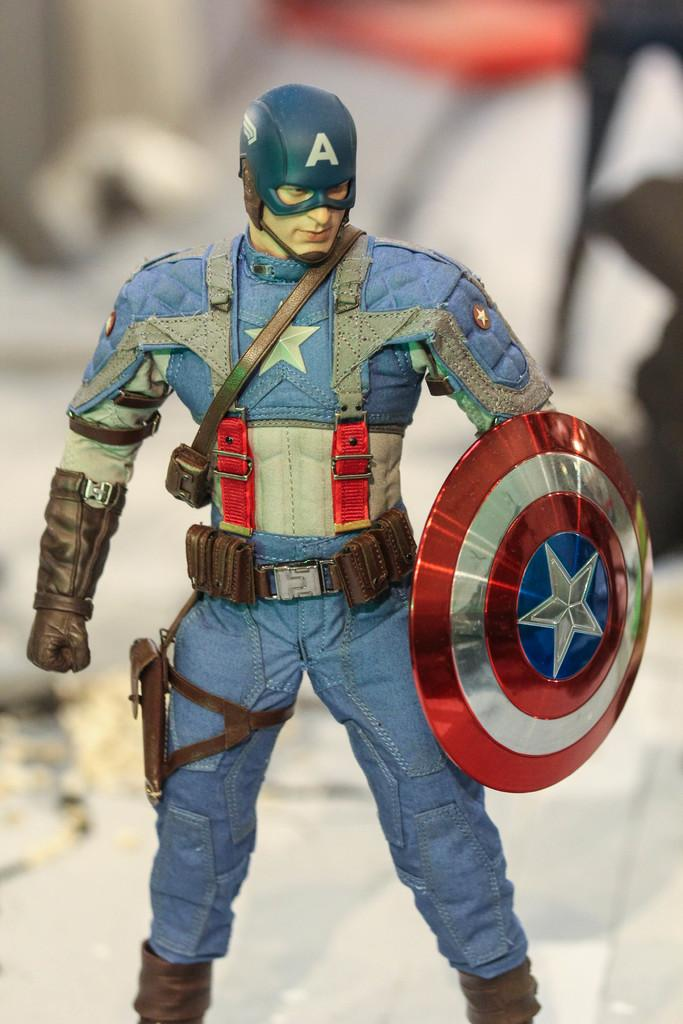What character is represented by the toy in the image? The toy in the image is of Captain America. What object is the toy holding? The toy is holding a shield. What colors can be seen on the shield? The shield has red and silver colors. Can you describe the background of the image? The background of the image is blurred. How many boxes are stacked on top of each other in the image? There are no boxes present in the image. What type of cloth is draped over the toy in the image? There is no cloth draped over the toy in the image. 